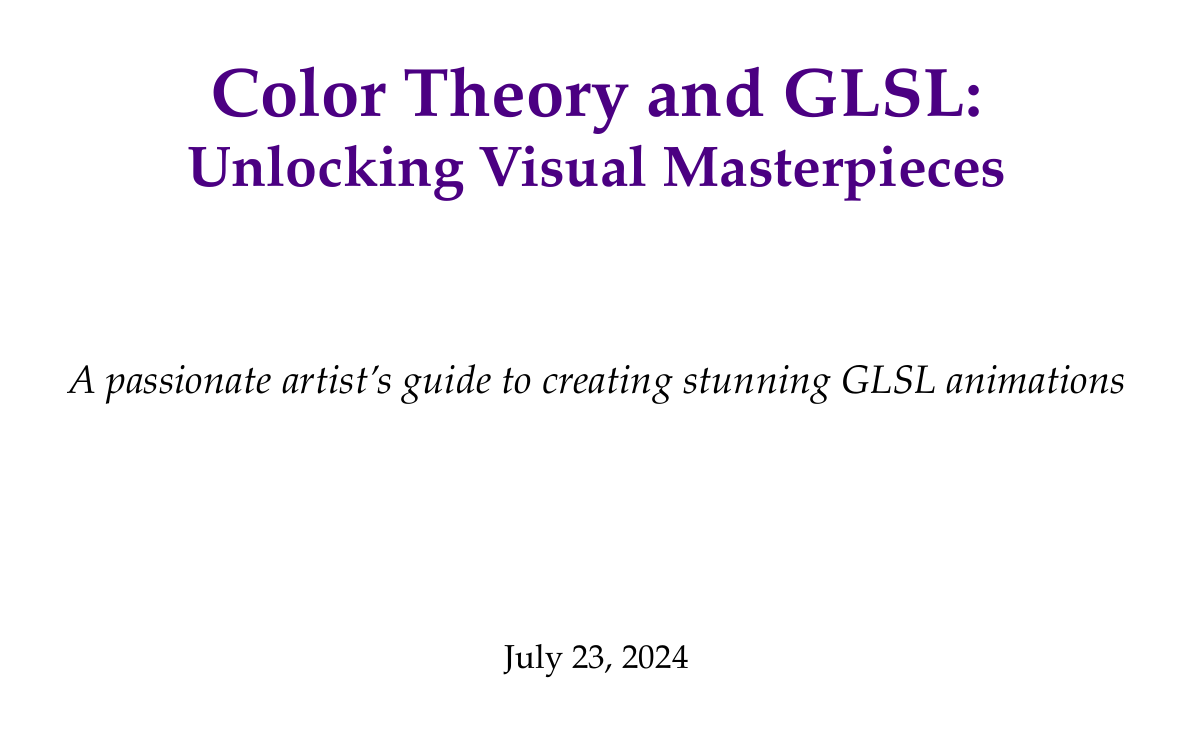What is the title of the report? The title of the report is provided in the title page as the main focus of the document.
Answer: Color Theory and GLSL: Unlocking Visual Masterpieces What are the primary color models mentioned? The advanced topics section of color theory discusses various color spaces, including primary models.
Answer: RGB, HSL, HSV Which digital artist worked on the project "Elevated"? The case studies section identifies the artist associated with the project through their analysis of color usage.
Answer: Inigo Quilez What technique did Patricio Gonzalez Vivo use for color variations? The techniques used in his project are listed, showcasing his approach to color in his works.
Answer: Perlin noise What is one of the skills developed in creating a mood-based color palette generator? The practical exercises section outlines specific skills the artist will gain by completing the project detailed.
Answer: Color harmony implementation How many case studies are presented in the document? The case studies section includes a clear list of artists and their projects.
Answer: Two 